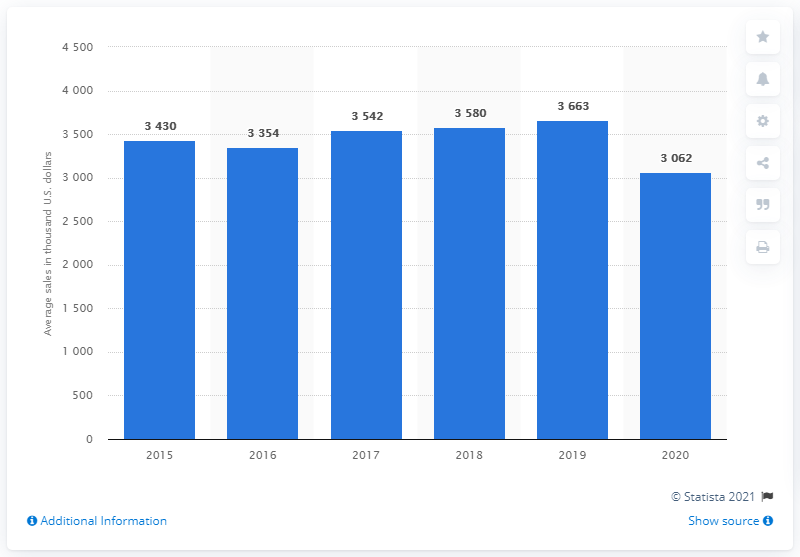Draw attention to some important aspects in this diagram. In 2020, the average sales per unit at Outback Steakhouse restaurants in the United States was 3,062. 